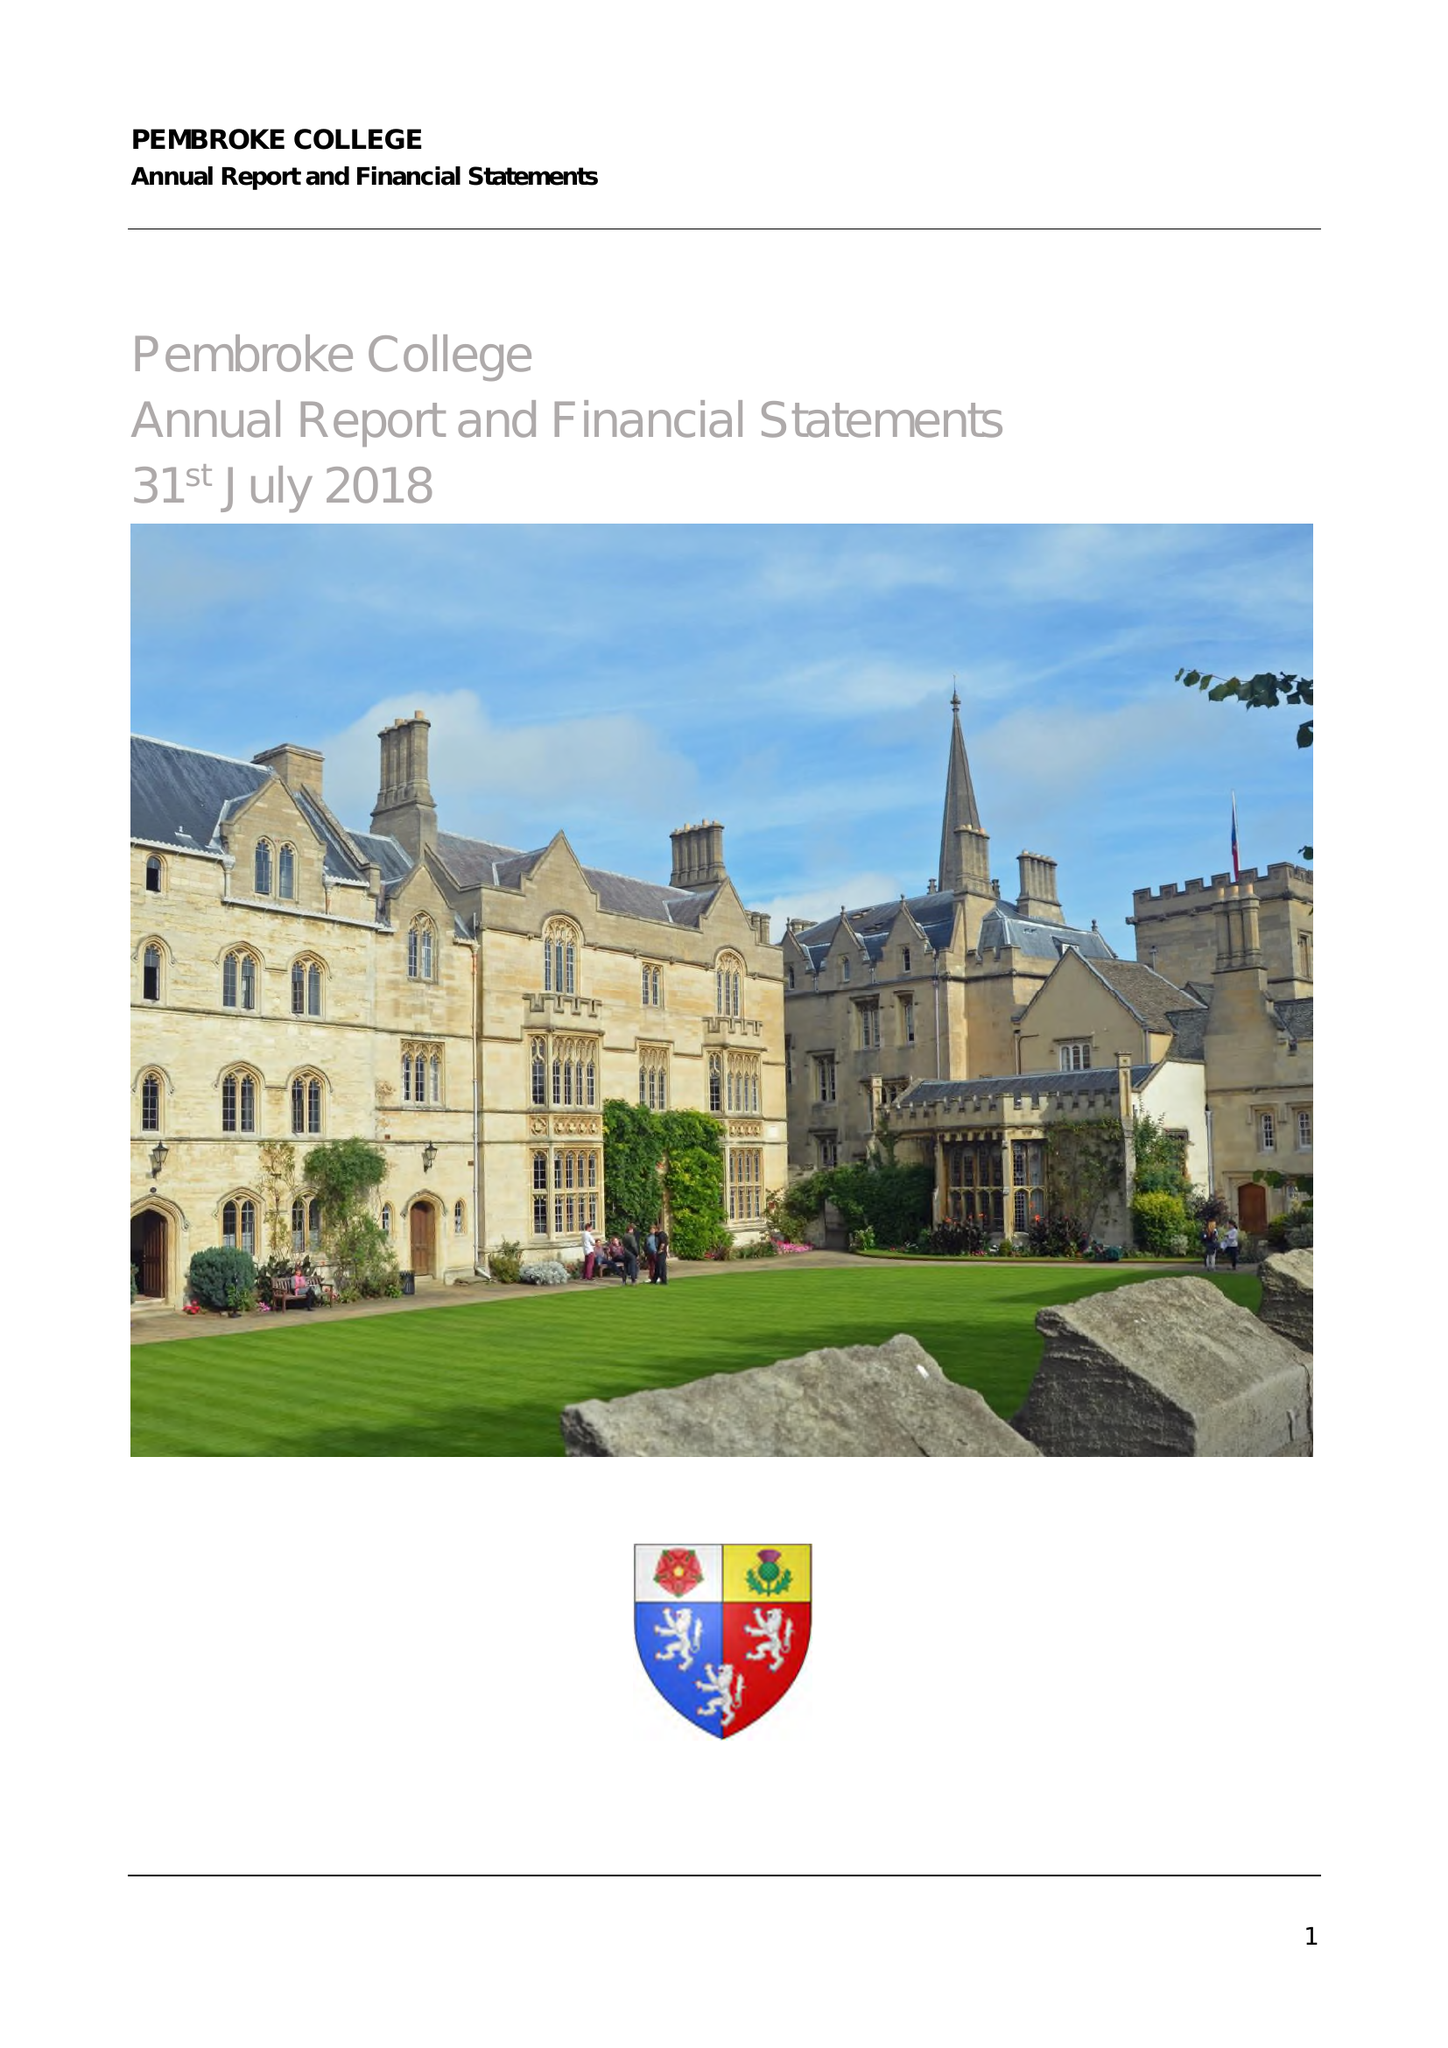What is the value for the address__street_line?
Answer the question using a single word or phrase. ST ALDATES 